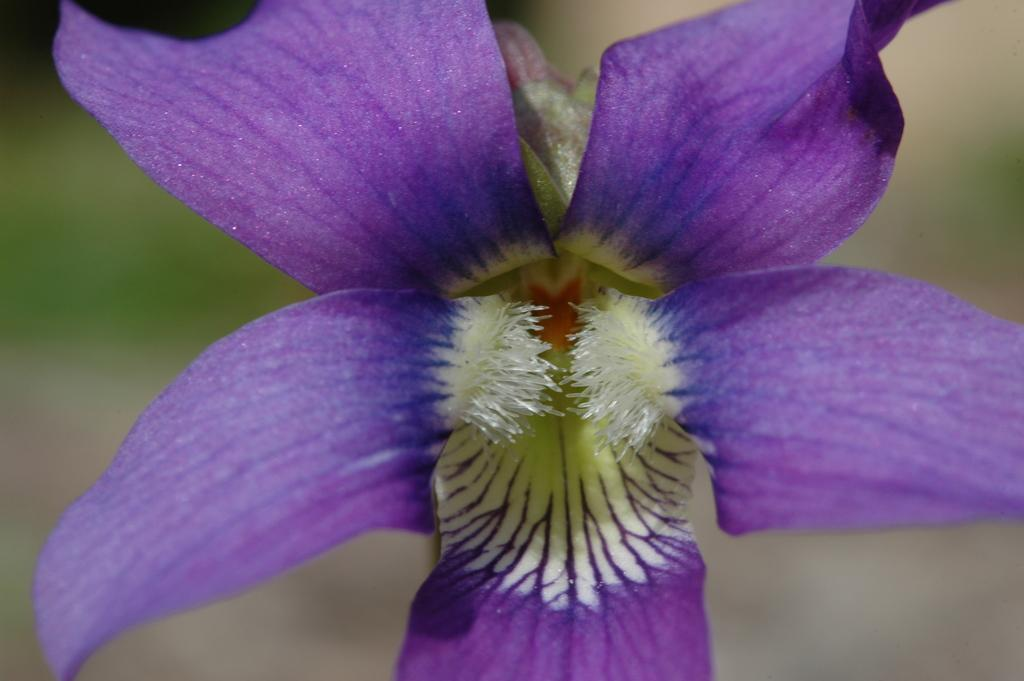What type of flower is in the image? There is a violet color flower in the image. Can you describe the background of the image? The background of the image is blurred. What advice does the uncle give about digestion in the image? There is no uncle present in the image, nor is there any discussion about digestion. 